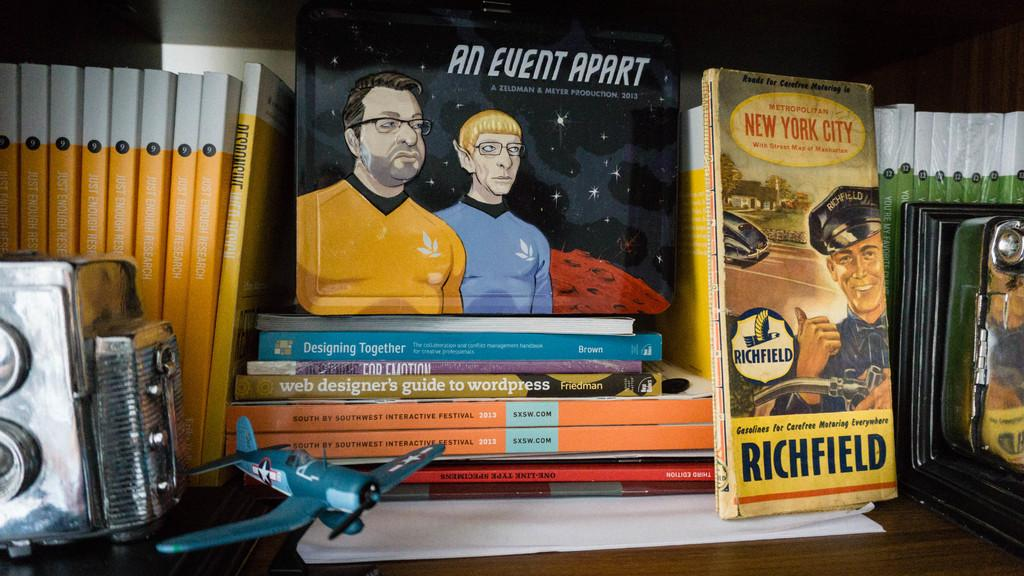<image>
Summarize the visual content of the image. Several books on a bookshelf with one about New York City. 